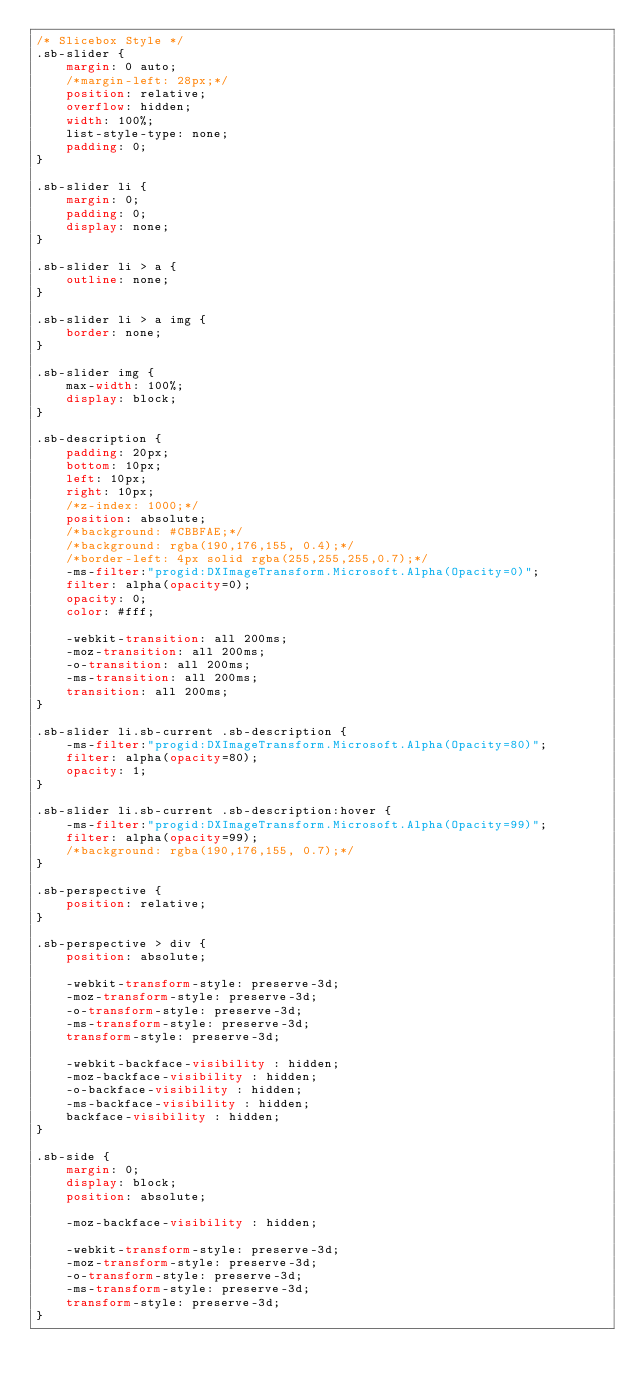Convert code to text. <code><loc_0><loc_0><loc_500><loc_500><_CSS_>/* Slicebox Style */
.sb-slider {
	margin: 0 auto;
	/*margin-left: 28px;*/
	position: relative;
	overflow: hidden;
	width: 100%;
	list-style-type: none;
	padding: 0;
}

.sb-slider li {
	margin: 0;
	padding: 0;
	display: none;
}

.sb-slider li > a {
	outline: none;
}

.sb-slider li > a img {
	border: none;
}

.sb-slider img {
	max-width: 100%;
	display: block;
}

.sb-description {
	padding: 20px;
	bottom: 10px;
	left: 10px;
	right: 10px;
	/*z-index: 1000;*/
	position: absolute;
	/*background: #CBBFAE;*/
	/*background: rgba(190,176,155, 0.4);*/
	/*border-left: 4px solid rgba(255,255,255,0.7);*/
	-ms-filter:"progid:DXImageTransform.Microsoft.Alpha(Opacity=0)";
	filter: alpha(opacity=0);
	opacity: 0;
	color: #fff;

	-webkit-transition: all 200ms;
	-moz-transition: all 200ms;
	-o-transition: all 200ms;
	-ms-transition: all 200ms;
	transition: all 200ms;
}

.sb-slider li.sb-current .sb-description {
	-ms-filter:"progid:DXImageTransform.Microsoft.Alpha(Opacity=80)";
	filter: alpha(opacity=80);
	opacity: 1;
}

.sb-slider li.sb-current .sb-description:hover {
	-ms-filter:"progid:DXImageTransform.Microsoft.Alpha(Opacity=99)";
	filter: alpha(opacity=99);
	/*background: rgba(190,176,155, 0.7);*/
}

.sb-perspective {
	position: relative;
}

.sb-perspective > div {
	position: absolute;

	-webkit-transform-style: preserve-3d;
	-moz-transform-style: preserve-3d;
	-o-transform-style: preserve-3d;
	-ms-transform-style: preserve-3d;
	transform-style: preserve-3d;

	-webkit-backface-visibility : hidden;
	-moz-backface-visibility : hidden;
	-o-backface-visibility : hidden;
	-ms-backface-visibility : hidden;
	backface-visibility : hidden;
}

.sb-side {
	margin: 0;
	display: block;
	position: absolute;

	-moz-backface-visibility : hidden;

	-webkit-transform-style: preserve-3d;
	-moz-transform-style: preserve-3d;
	-o-transform-style: preserve-3d;
	-ms-transform-style: preserve-3d;
	transform-style: preserve-3d;
}
</code> 